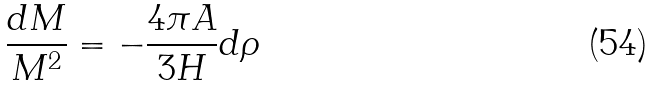<formula> <loc_0><loc_0><loc_500><loc_500>\frac { d M } { M ^ { 2 } } = - \frac { 4 \pi A } { 3 H } d \rho</formula> 